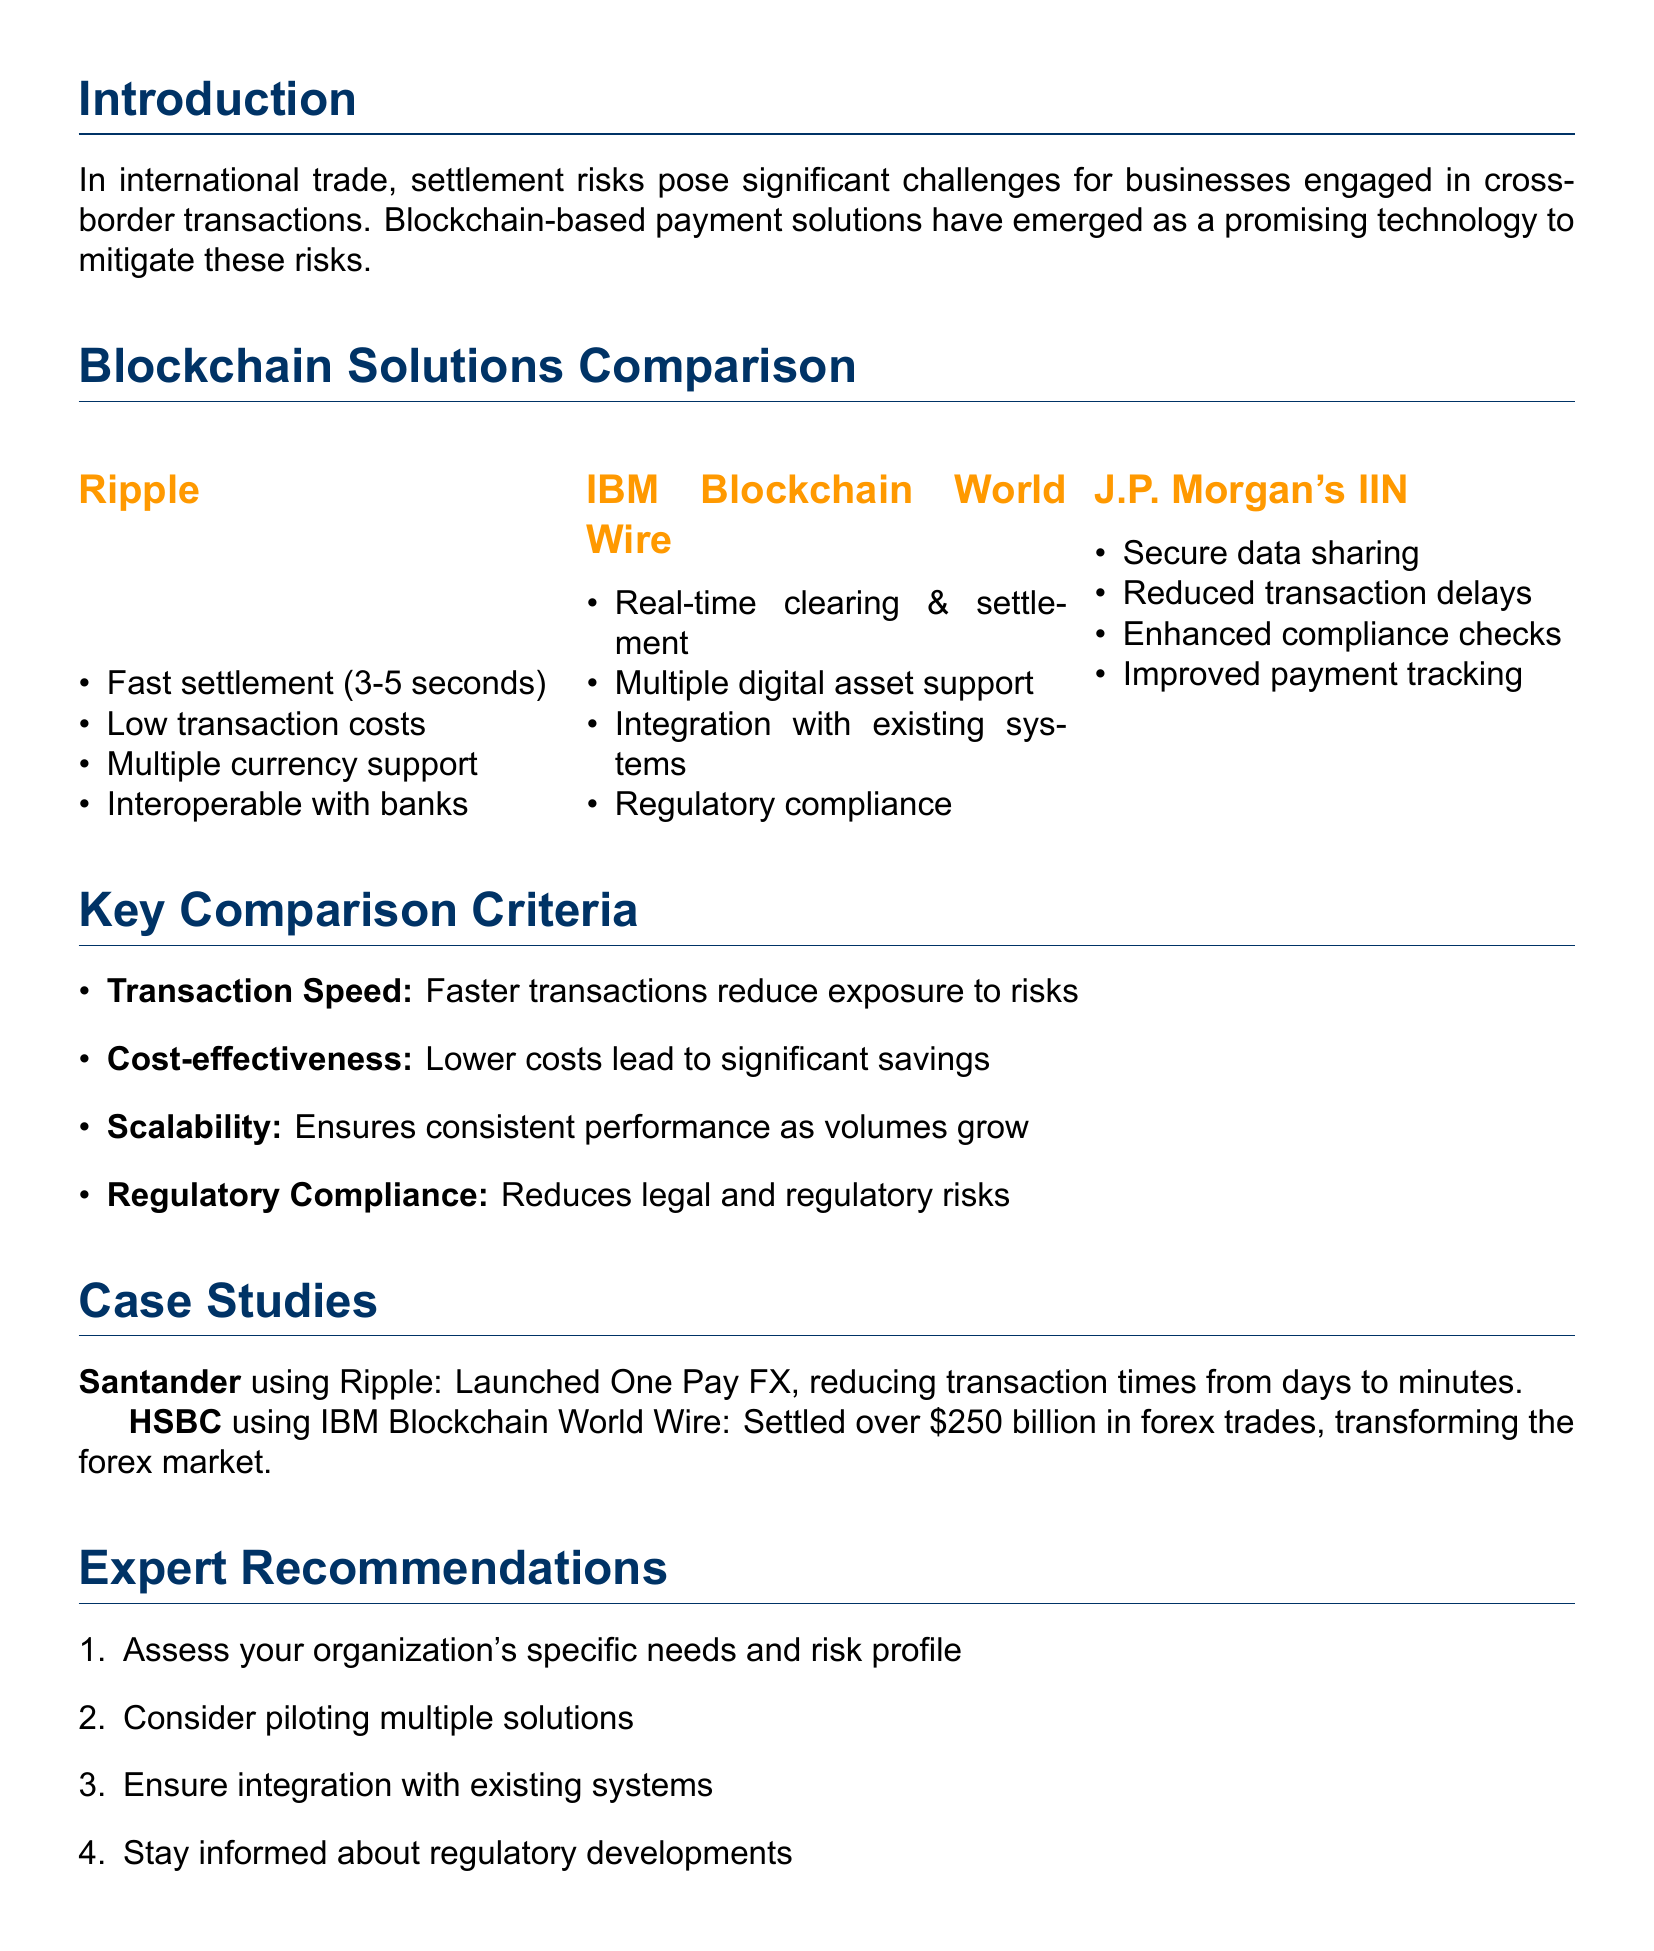What is the main context described in the introduction? The introduction discusses the challenges of settlement risks in international trade and how blockchain-based payment solutions can mitigate these risks.
Answer: Settlement risks What are the key features of Ripple? The document lists key features including fast transaction settlement and low transaction costs.
Answer: Fast transaction settlement, low transaction costs Which blockchain solution integrates with existing payment systems? IBM Blockchain World Wire is highlighted for its integration with existing payment systems.
Answer: IBM Blockchain World Wire What is one key criterion for comparing the blockchain solutions? The document mentions transaction speed as a key criterion for comparison.
Answer: Transaction speed What company launched a blockchain-based international payment service using Ripple? Santander is mentioned as the company that launched the One Pay FX service using Ripple.
Answer: Santander How much did HSBC settle in forex trades using IBM Blockchain World Wire? The document states that HSBC settled over $250 billion in forex trades.
Answer: $250 billion What expert recommendation is provided regarding regulatory developments? The document advises staying informed about regulatory developments related to blockchain.
Answer: Stay informed about regulatory developments Which solution is known for secure data sharing? J.P. Morgan's Interbank Information Network (IIN) is known for secure data sharing.
Answer: J.P. Morgan's Interbank Information Network (IIN) What does the conclusion summarize about blockchain payment solutions? The conclusion summarizes the significant potential of blockchain-based payment solutions in reducing settlement risks.
Answer: Significant potential 